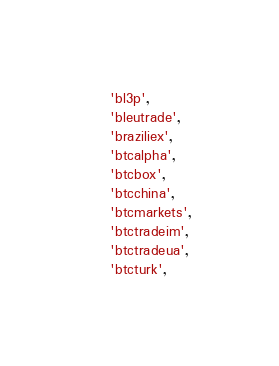Convert code to text. <code><loc_0><loc_0><loc_500><loc_500><_Python_>    'bl3p',
    'bleutrade',
    'braziliex',
    'btcalpha',
    'btcbox',
    'btcchina',
    'btcmarkets',
    'btctradeim',
    'btctradeua',
    'btcturk',</code> 